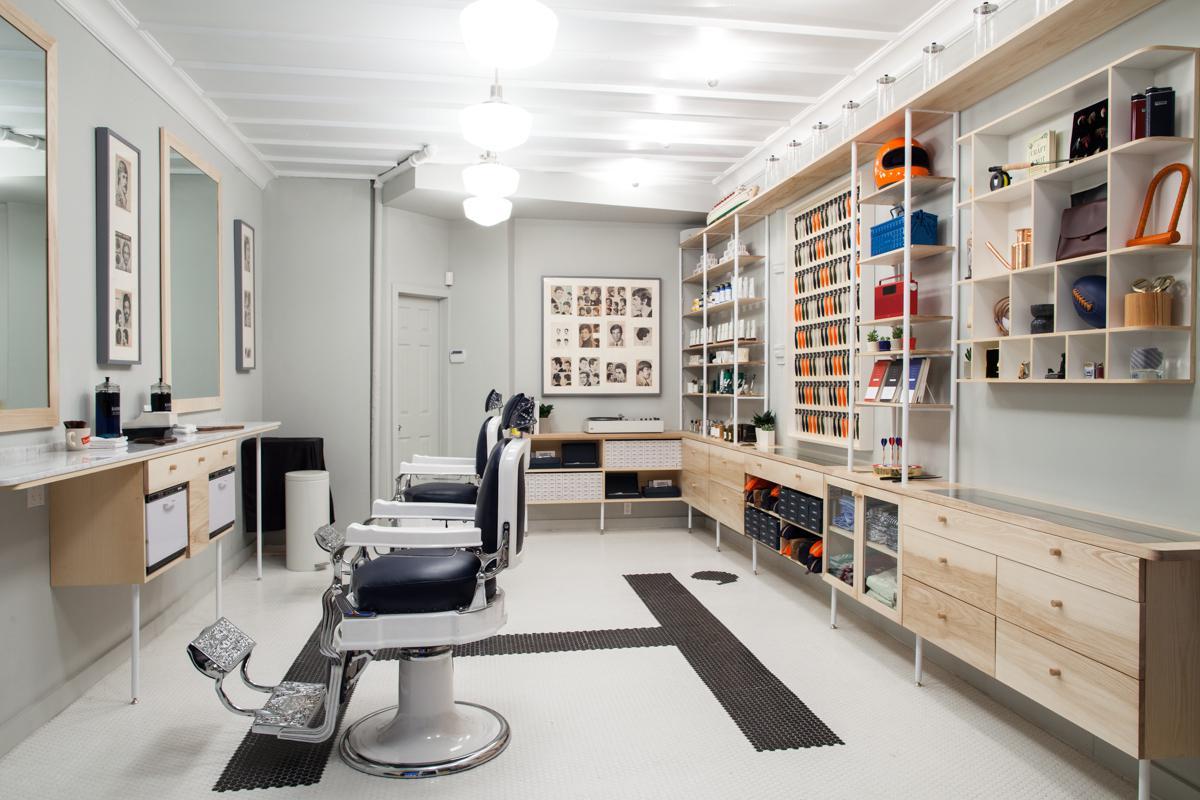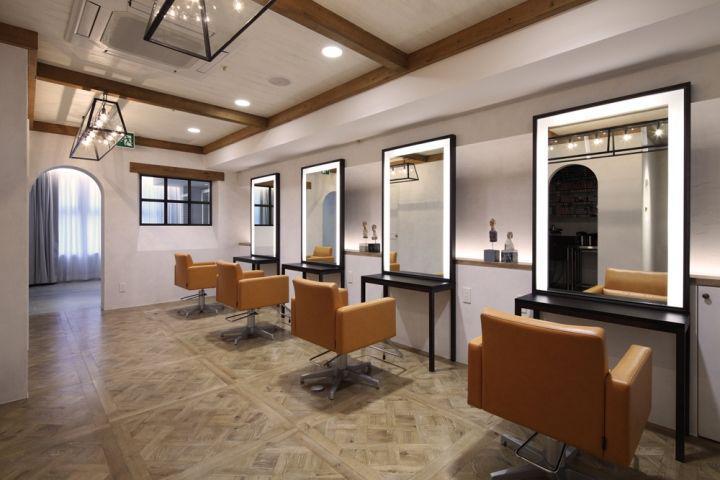The first image is the image on the left, the second image is the image on the right. Assess this claim about the two images: "There are mirrors on the right wall of the room in the image on the right". Correct or not? Answer yes or no. Yes. 